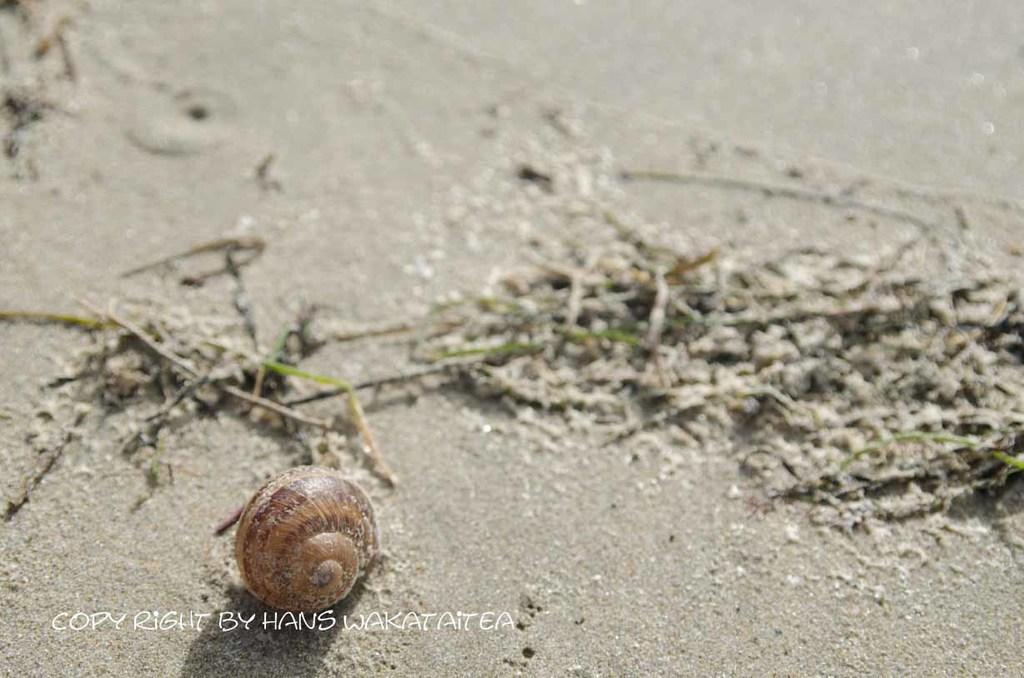What is the main object in the image? There is a shell in the image. What is the color of the mud where the shell is located? The shell is on grey color mud. What is the color of the shell? The shell is brown in color. What type of vegetation can be seen in the image? There is grass visible in the image. Can you tell me how many pairs of jeans are visible in the image? There are no jeans present in the image; it features a shell on grey color mud with grass nearby. 